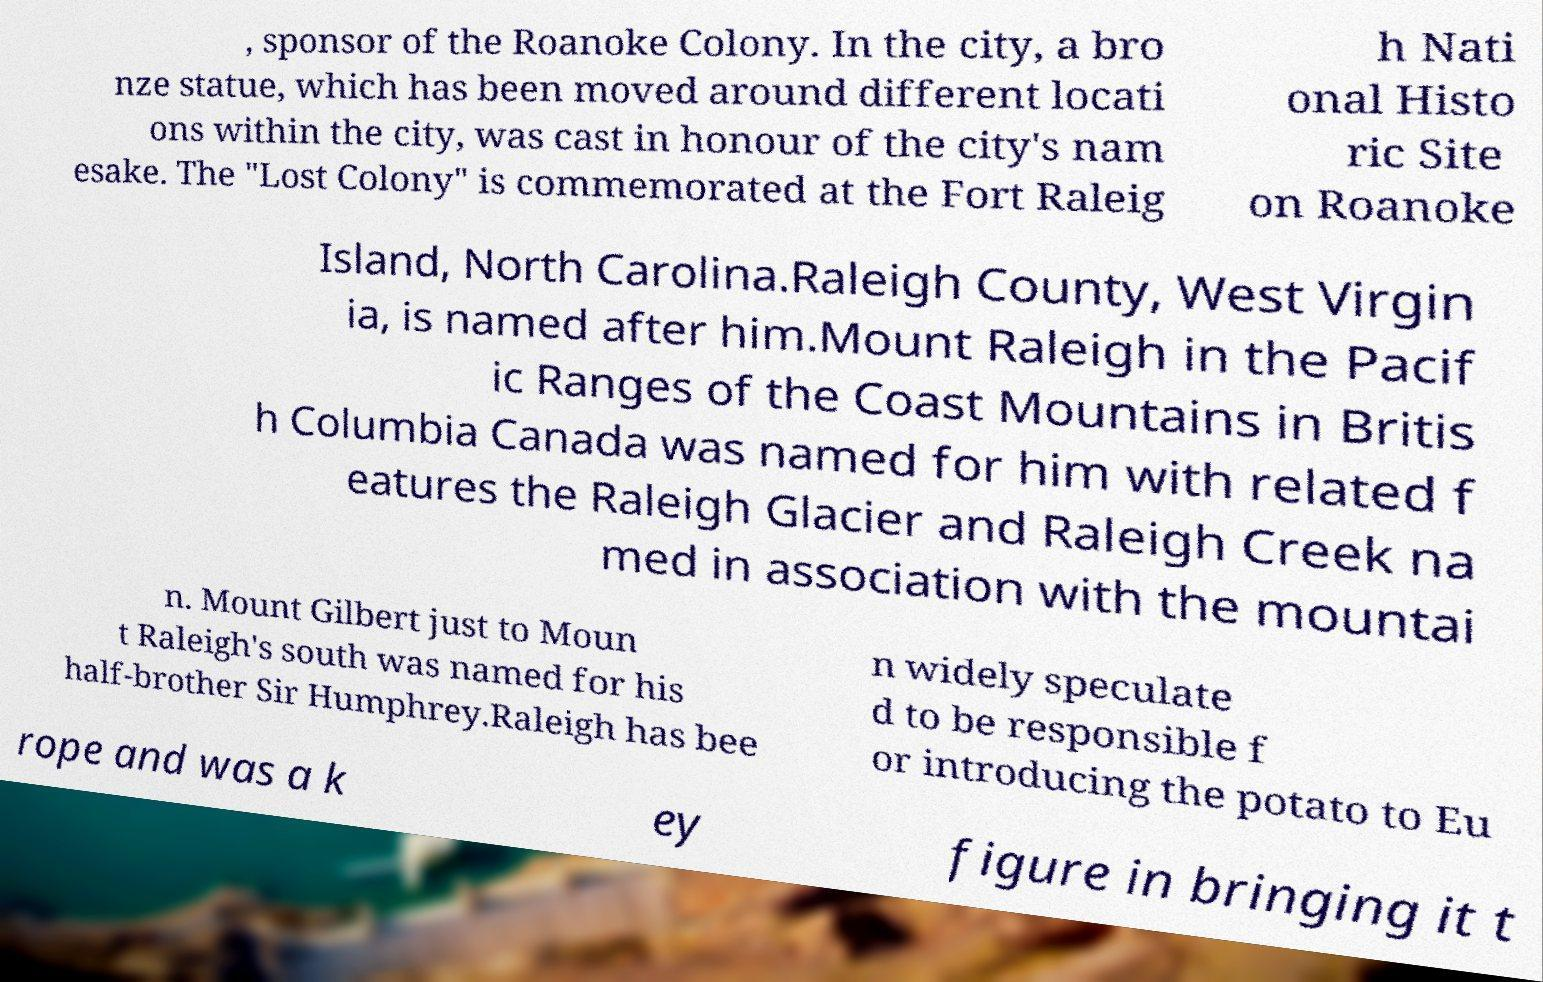Please identify and transcribe the text found in this image. , sponsor of the Roanoke Colony. In the city, a bro nze statue, which has been moved around different locati ons within the city, was cast in honour of the city's nam esake. The "Lost Colony" is commemorated at the Fort Raleig h Nati onal Histo ric Site on Roanoke Island, North Carolina.Raleigh County, West Virgin ia, is named after him.Mount Raleigh in the Pacif ic Ranges of the Coast Mountains in Britis h Columbia Canada was named for him with related f eatures the Raleigh Glacier and Raleigh Creek na med in association with the mountai n. Mount Gilbert just to Moun t Raleigh's south was named for his half-brother Sir Humphrey.Raleigh has bee n widely speculate d to be responsible f or introducing the potato to Eu rope and was a k ey figure in bringing it t 